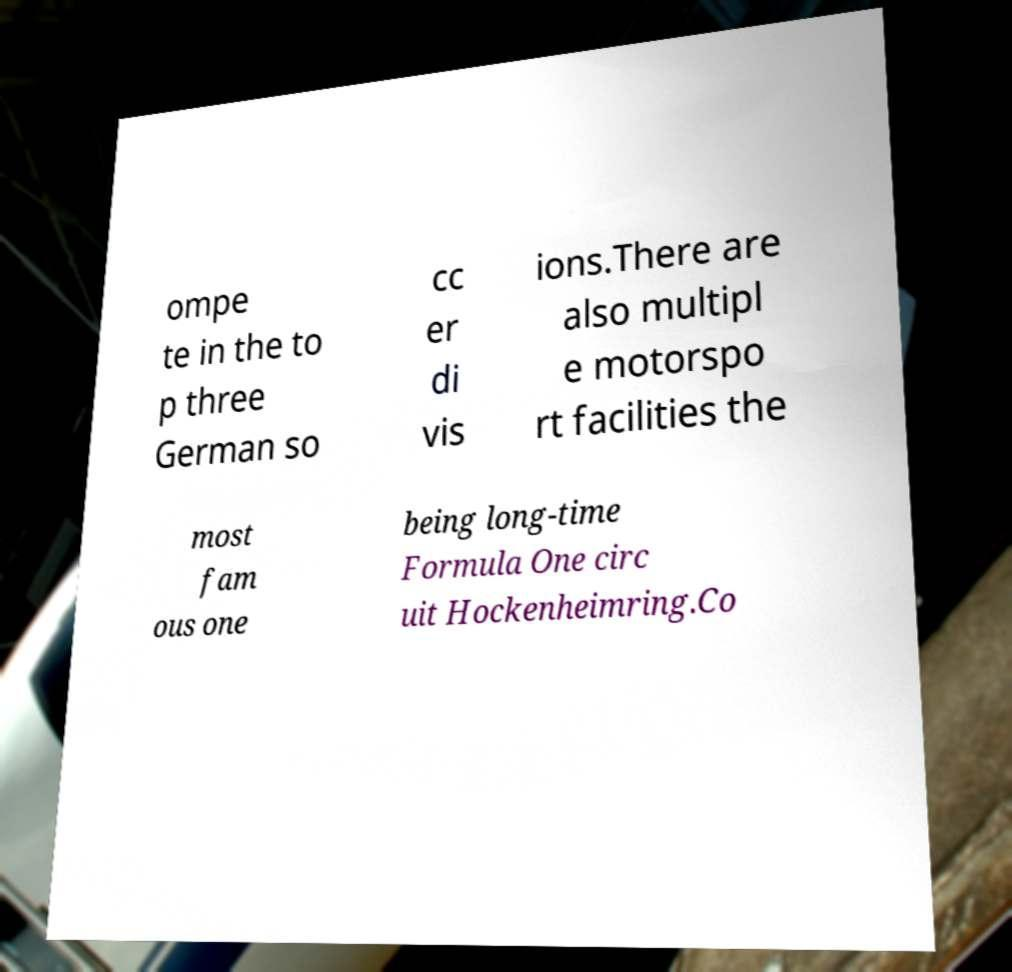Please read and relay the text visible in this image. What does it say? ompe te in the to p three German so cc er di vis ions.There are also multipl e motorspo rt facilities the most fam ous one being long-time Formula One circ uit Hockenheimring.Co 